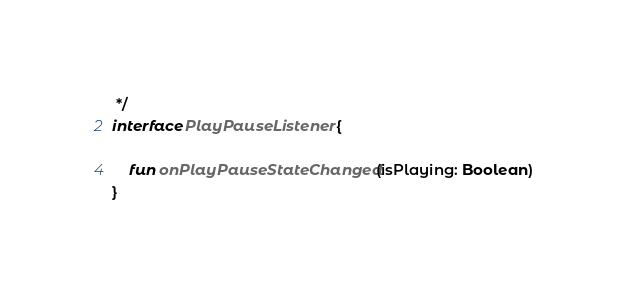Convert code to text. <code><loc_0><loc_0><loc_500><loc_500><_Kotlin_> */
interface PlayPauseListener {

    fun onPlayPauseStateChanged(isPlaying: Boolean)
}</code> 